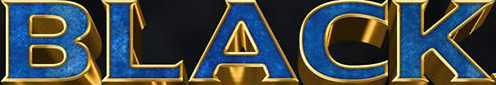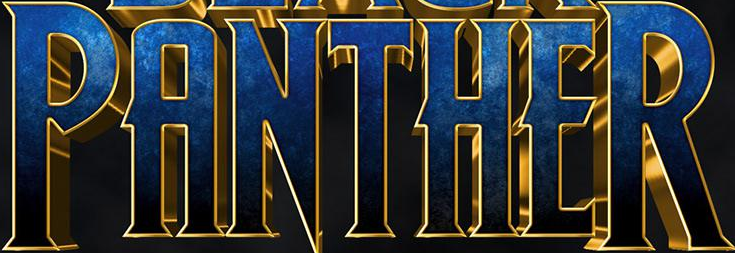Read the text from these images in sequence, separated by a semicolon. BLACK; PANTHER 